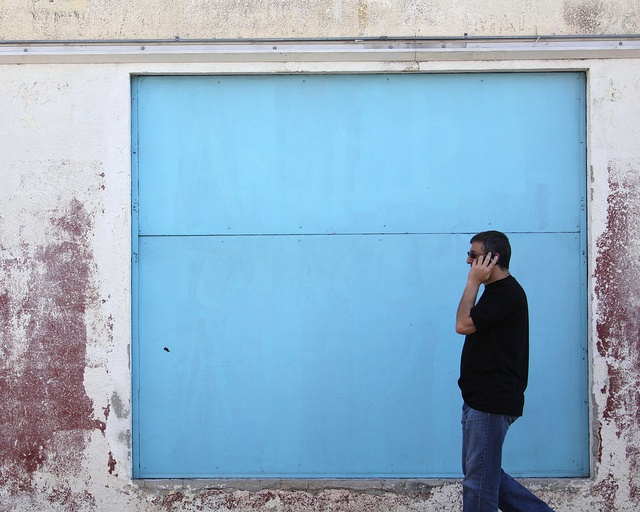Describe the objects in this image and their specific colors. I can see people in beige, black, navy, and gray tones and cell phone in black, gray, darkgray, and beige tones in this image. 